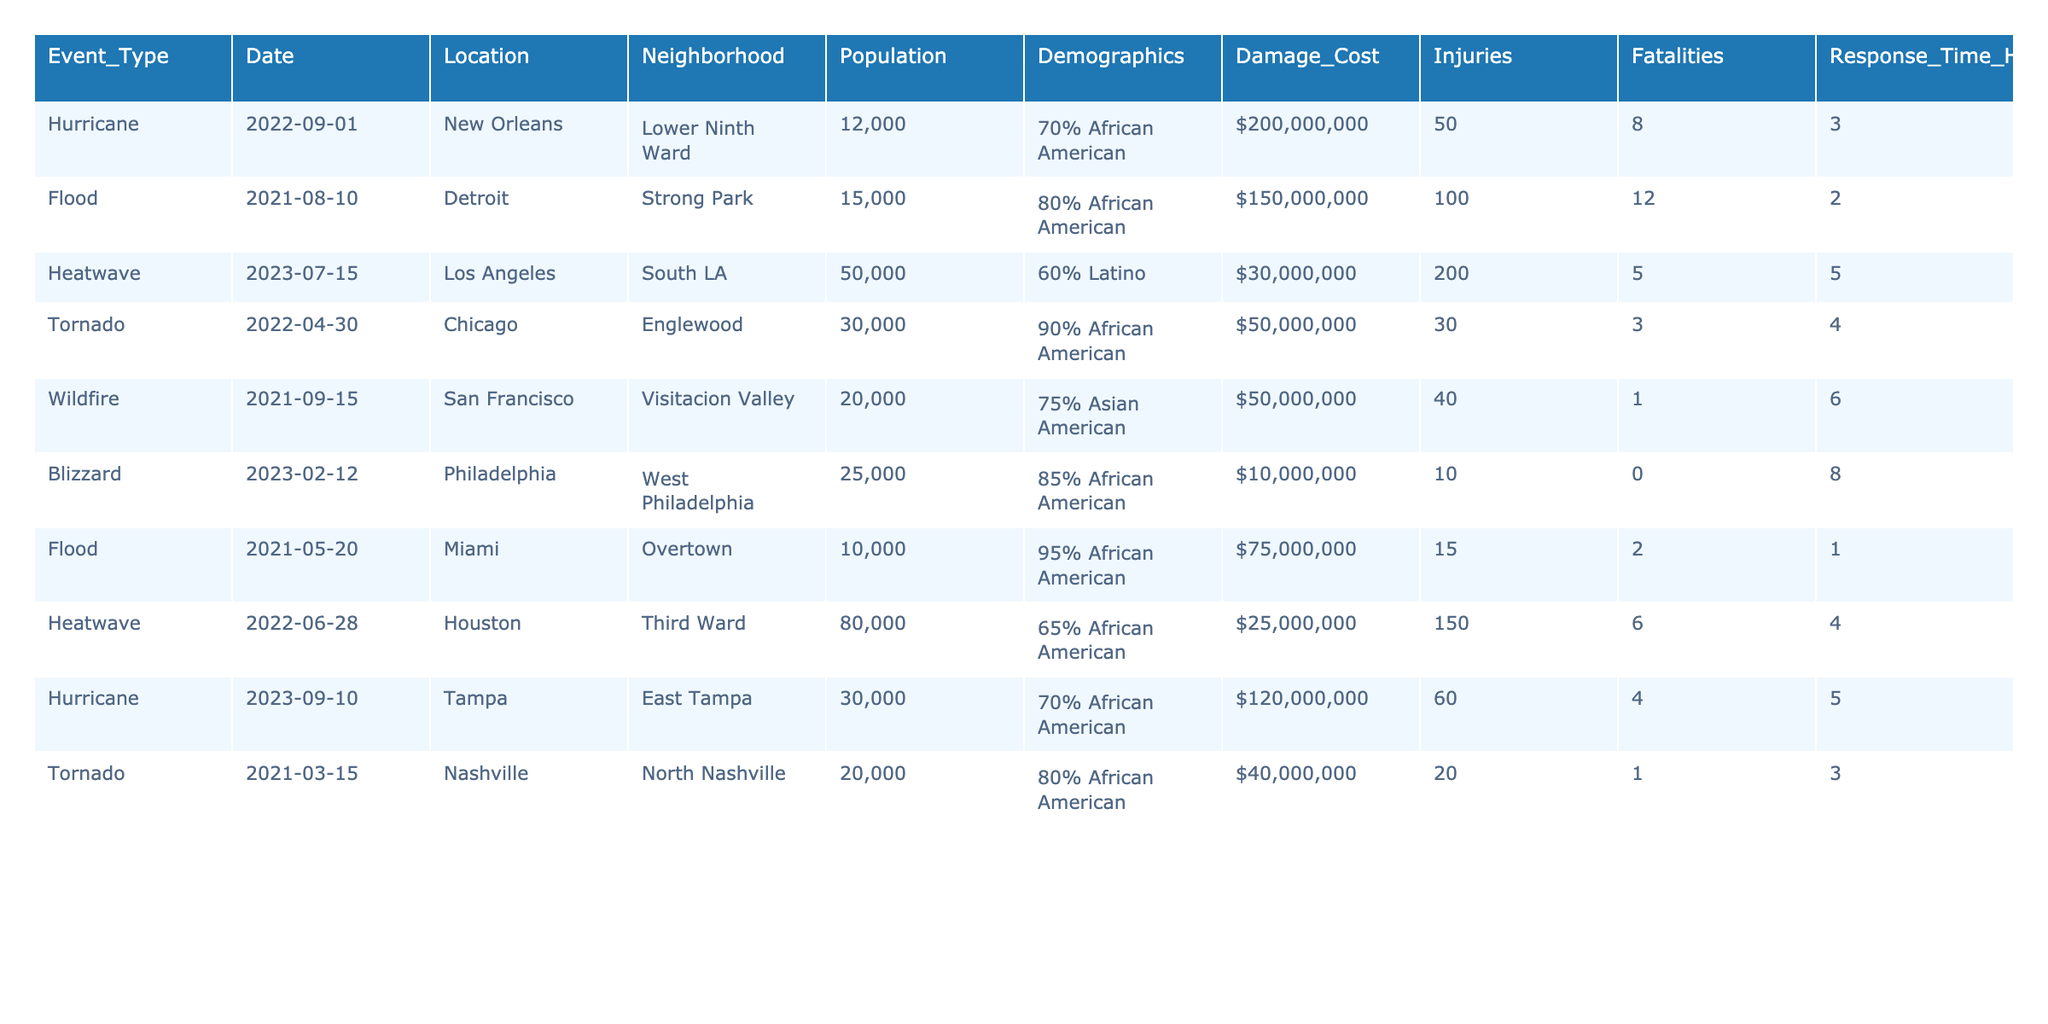What was the total damage cost from extreme weather events in the neighborhoods listed? To find the total damage cost, I will add the damage costs from each event: $200,000,000 + $150,000,000 + $30,000,000 + $50,000,000 + $50,000,000 + $10,000,000 + $75,000,000 + $25,000,000 + $120,000,000 + $40,000,000 = $1,250,000,000.
Answer: $1,250,000,000 Which neighborhood experienced the highest number of injuries during extreme weather events? The injuries for each neighborhood are as follows: Lower Ninth Ward (50), Strong Park (100), South LA (200), Englewood (30), Visitacion Valley (40), West Philadelphia (10), Overtown (15), Third Ward (150), East Tampa (60), North Nashville (20). The highest is South LA with 200 injuries.
Answer: South LA How many fatalities resulted from the extreme weather events listed in the table? I will sum the fatalities from each event: 8 + 12 + 5 + 3 + 1 + 0 + 2 + 6 + 4 + 1 = 42.
Answer: 42 Did any event occur in a neighborhood with a population over 80,000? The neighborhoods and their populations are: Lower Ninth Ward (12,000), Strong Park (15,000), South LA (50,000), Englewood (30,000), Visitacion Valley (20,000), West Philadelphia (25,000), Overtown (10,000), Third Ward (80,000), East Tampa (30,000), North Nashville (20,000). None exceeds 80,000 when excluding the Third Ward which equals 80,000.
Answer: No Which event had the longest response time, and what was that time? Review the response times: 3, 2, 5, 4, 6, 8, 1, 4, 5, 3 hours respectively. The longest time is 8 hours from the blizzard in West Philadelphia.
Answer: 8 hours from the blizzard in West Philadelphia What is the demographic percentage of the Lower Ninth Ward neighborhood? The table indicates that the demographic percentage for the Lower Ninth Ward is 70% African American.
Answer: 70% African American Calculate the average number of fatalities across all events listed. Add the fatalities and divide by the number of events: (8 + 12 + 5 + 3 + 1 + 0 + 2 + 6 + 4 + 1) / 10 = 42 / 10 = 4.2.
Answer: 4.2 Is there an event that caused at least $100 million in damages? By checking the damage costs, the only one that meets this criterion is the hurricane in Lower Ninth Ward ($200,000,000).
Answer: Yes How many neighborhoods listed experienced flooding events? There are two flooding events listed, occurring in Strong Park and Overtown.
Answer: Two neighborhoods What is the total population of neighborhoods impacted by extreme weather events in the table? To find the total population, I will sum populations of the neighborhoods: 12,000 + 15,000 + 50,000 + 30,000 + 20,000 + 25,000 + 10,000 + 80,000 + 30,000 + 20,000 =  302,000.
Answer: 302,000 